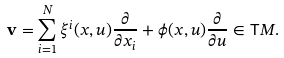<formula> <loc_0><loc_0><loc_500><loc_500>\mathbf v = \sum _ { i = 1 } ^ { N } \xi ^ { i } ( x , u ) \frac { \partial } { \partial x _ { i } } + \phi ( x , u ) \frac { \partial } { \partial u } \in \mathsf T M .</formula> 